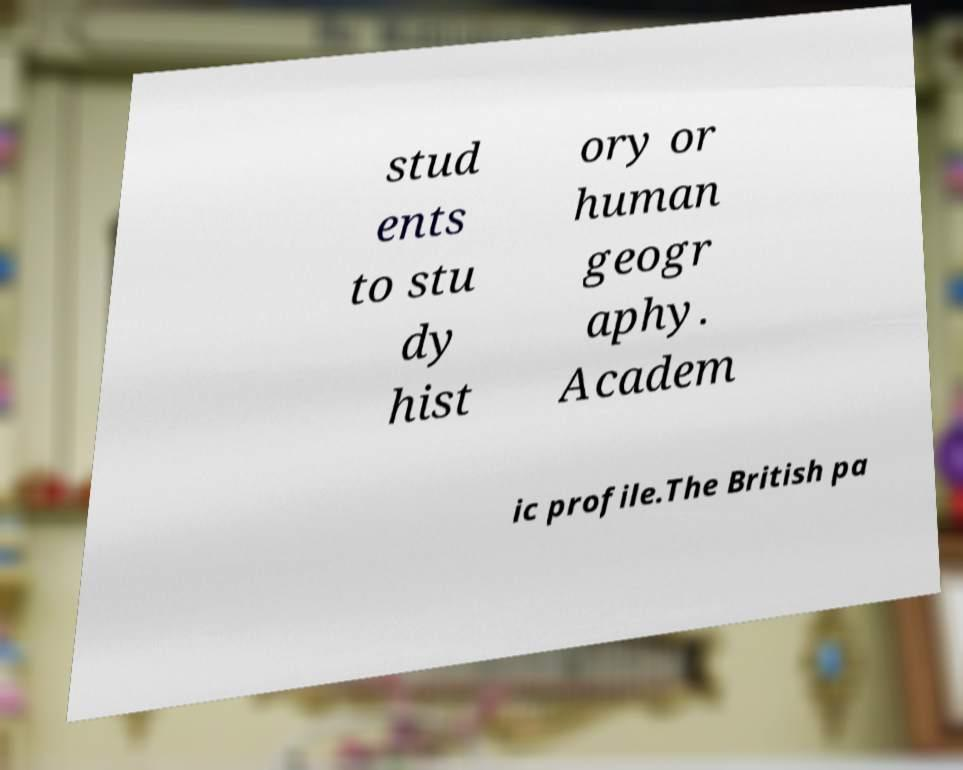Please identify and transcribe the text found in this image. stud ents to stu dy hist ory or human geogr aphy. Academ ic profile.The British pa 